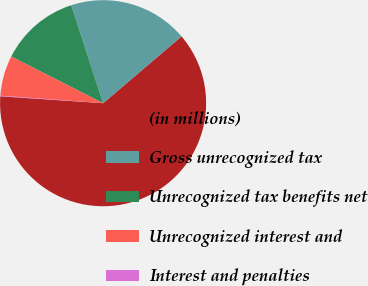<chart> <loc_0><loc_0><loc_500><loc_500><pie_chart><fcel>(in millions)<fcel>Gross unrecognized tax<fcel>Unrecognized tax benefits net<fcel>Unrecognized interest and<fcel>Interest and penalties<nl><fcel>62.3%<fcel>18.76%<fcel>12.53%<fcel>6.31%<fcel>0.09%<nl></chart> 